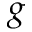<formula> <loc_0><loc_0><loc_500><loc_500>g</formula> 